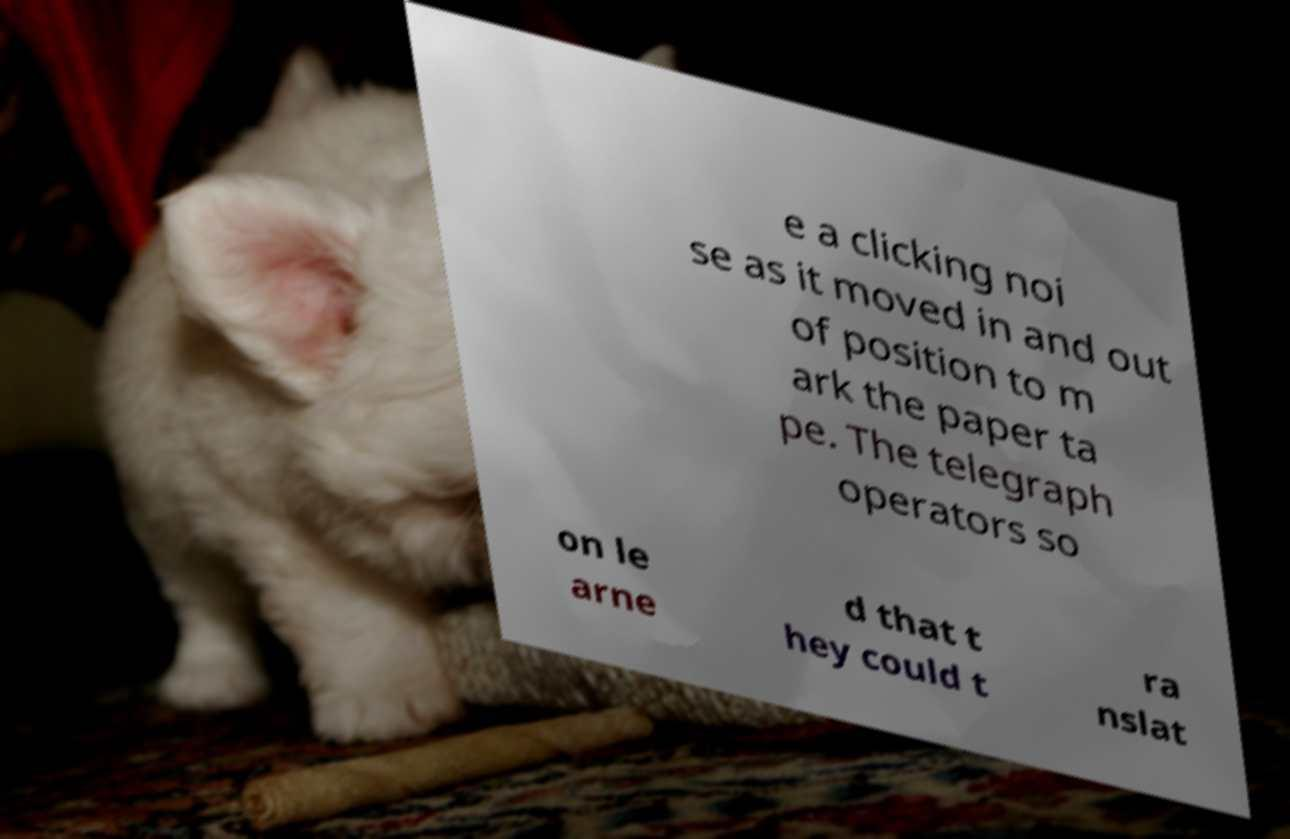For documentation purposes, I need the text within this image transcribed. Could you provide that? e a clicking noi se as it moved in and out of position to m ark the paper ta pe. The telegraph operators so on le arne d that t hey could t ra nslat 